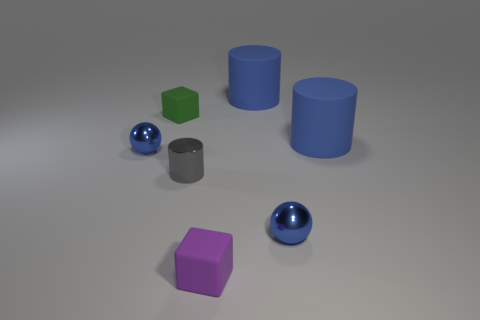Subtract all blue cylinders. How many cylinders are left? 1 Subtract all purple cubes. How many cubes are left? 1 Subtract all cubes. How many objects are left? 5 Subtract 2 spheres. How many spheres are left? 0 Subtract all purple cubes. Subtract all purple spheres. How many cubes are left? 1 Subtract all red cylinders. How many green blocks are left? 1 Subtract all small purple shiny balls. Subtract all large rubber objects. How many objects are left? 5 Add 4 balls. How many balls are left? 6 Add 3 big gray metal cylinders. How many big gray metal cylinders exist? 3 Add 3 gray metallic objects. How many objects exist? 10 